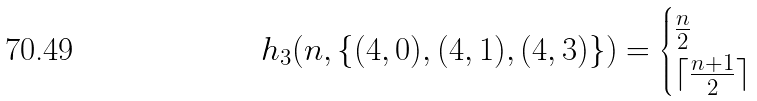Convert formula to latex. <formula><loc_0><loc_0><loc_500><loc_500>h _ { 3 } ( n , \{ ( 4 , 0 ) , ( 4 , 1 ) , ( 4 , 3 ) \} ) = \begin{cases} \frac { n } { 2 } & \\ \lceil \frac { n + 1 } { 2 } \rceil & \end{cases}</formula> 